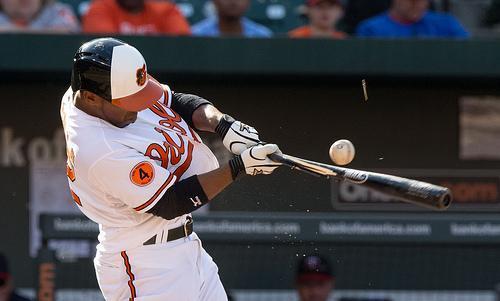How many baseballs are visible?
Give a very brief answer. 1. 